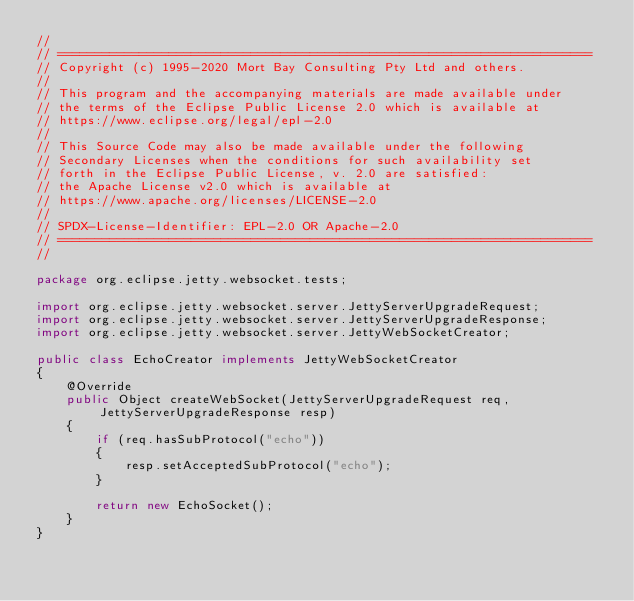Convert code to text. <code><loc_0><loc_0><loc_500><loc_500><_Java_>//
// ========================================================================
// Copyright (c) 1995-2020 Mort Bay Consulting Pty Ltd and others.
//
// This program and the accompanying materials are made available under
// the terms of the Eclipse Public License 2.0 which is available at
// https://www.eclipse.org/legal/epl-2.0
//
// This Source Code may also be made available under the following
// Secondary Licenses when the conditions for such availability set
// forth in the Eclipse Public License, v. 2.0 are satisfied:
// the Apache License v2.0 which is available at
// https://www.apache.org/licenses/LICENSE-2.0
//
// SPDX-License-Identifier: EPL-2.0 OR Apache-2.0
// ========================================================================
//

package org.eclipse.jetty.websocket.tests;

import org.eclipse.jetty.websocket.server.JettyServerUpgradeRequest;
import org.eclipse.jetty.websocket.server.JettyServerUpgradeResponse;
import org.eclipse.jetty.websocket.server.JettyWebSocketCreator;

public class EchoCreator implements JettyWebSocketCreator
{
    @Override
    public Object createWebSocket(JettyServerUpgradeRequest req, JettyServerUpgradeResponse resp)
    {
        if (req.hasSubProtocol("echo"))
        {
            resp.setAcceptedSubProtocol("echo");
        }

        return new EchoSocket();
    }
}
</code> 